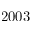Convert formula to latex. <formula><loc_0><loc_0><loc_500><loc_500>2 0 0 3</formula> 